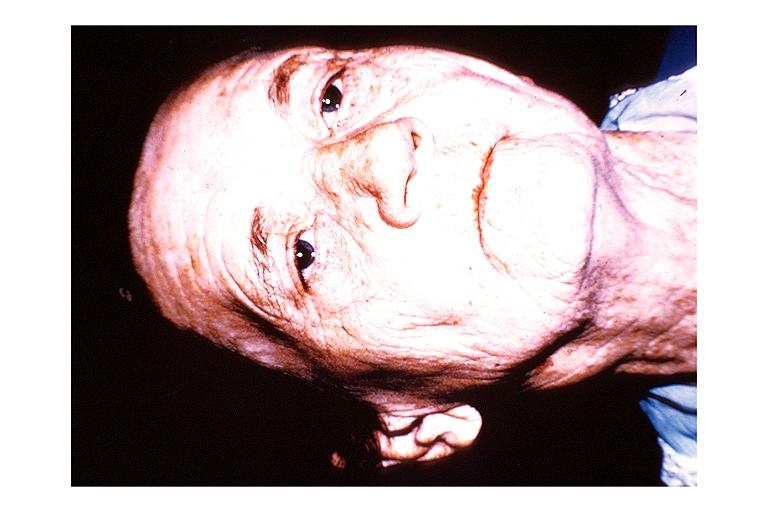what is present?
Answer the question using a single word or phrase. Oral 